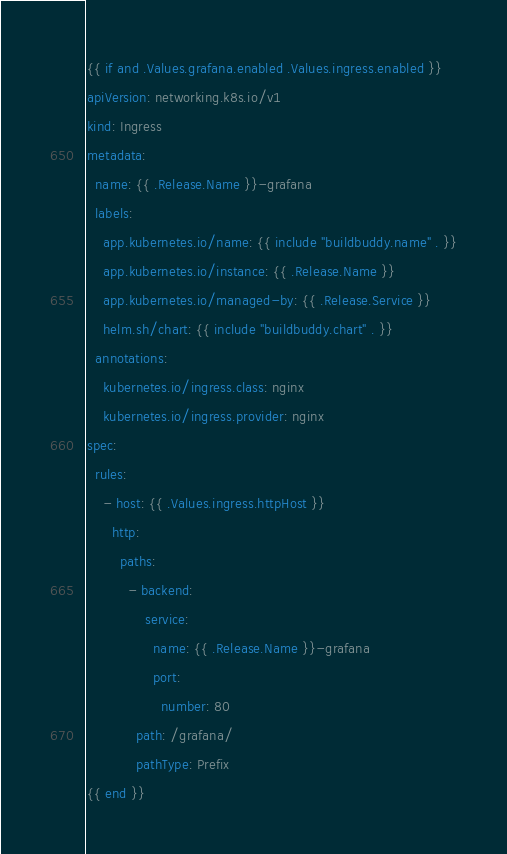<code> <loc_0><loc_0><loc_500><loc_500><_YAML_>{{ if and .Values.grafana.enabled .Values.ingress.enabled }}
apiVersion: networking.k8s.io/v1
kind: Ingress
metadata:
  name: {{ .Release.Name }}-grafana
  labels:
    app.kubernetes.io/name: {{ include "buildbuddy.name" . }}
    app.kubernetes.io/instance: {{ .Release.Name }}
    app.kubernetes.io/managed-by: {{ .Release.Service }}
    helm.sh/chart: {{ include "buildbuddy.chart" . }}
  annotations:
    kubernetes.io/ingress.class: nginx
    kubernetes.io/ingress.provider: nginx
spec:
  rules:
    - host: {{ .Values.ingress.httpHost }}
      http:
        paths:
          - backend:
              service:
                name: {{ .Release.Name }}-grafana
                port: 
                  number: 80
            path: /grafana/
            pathType: Prefix
{{ end }}
</code> 